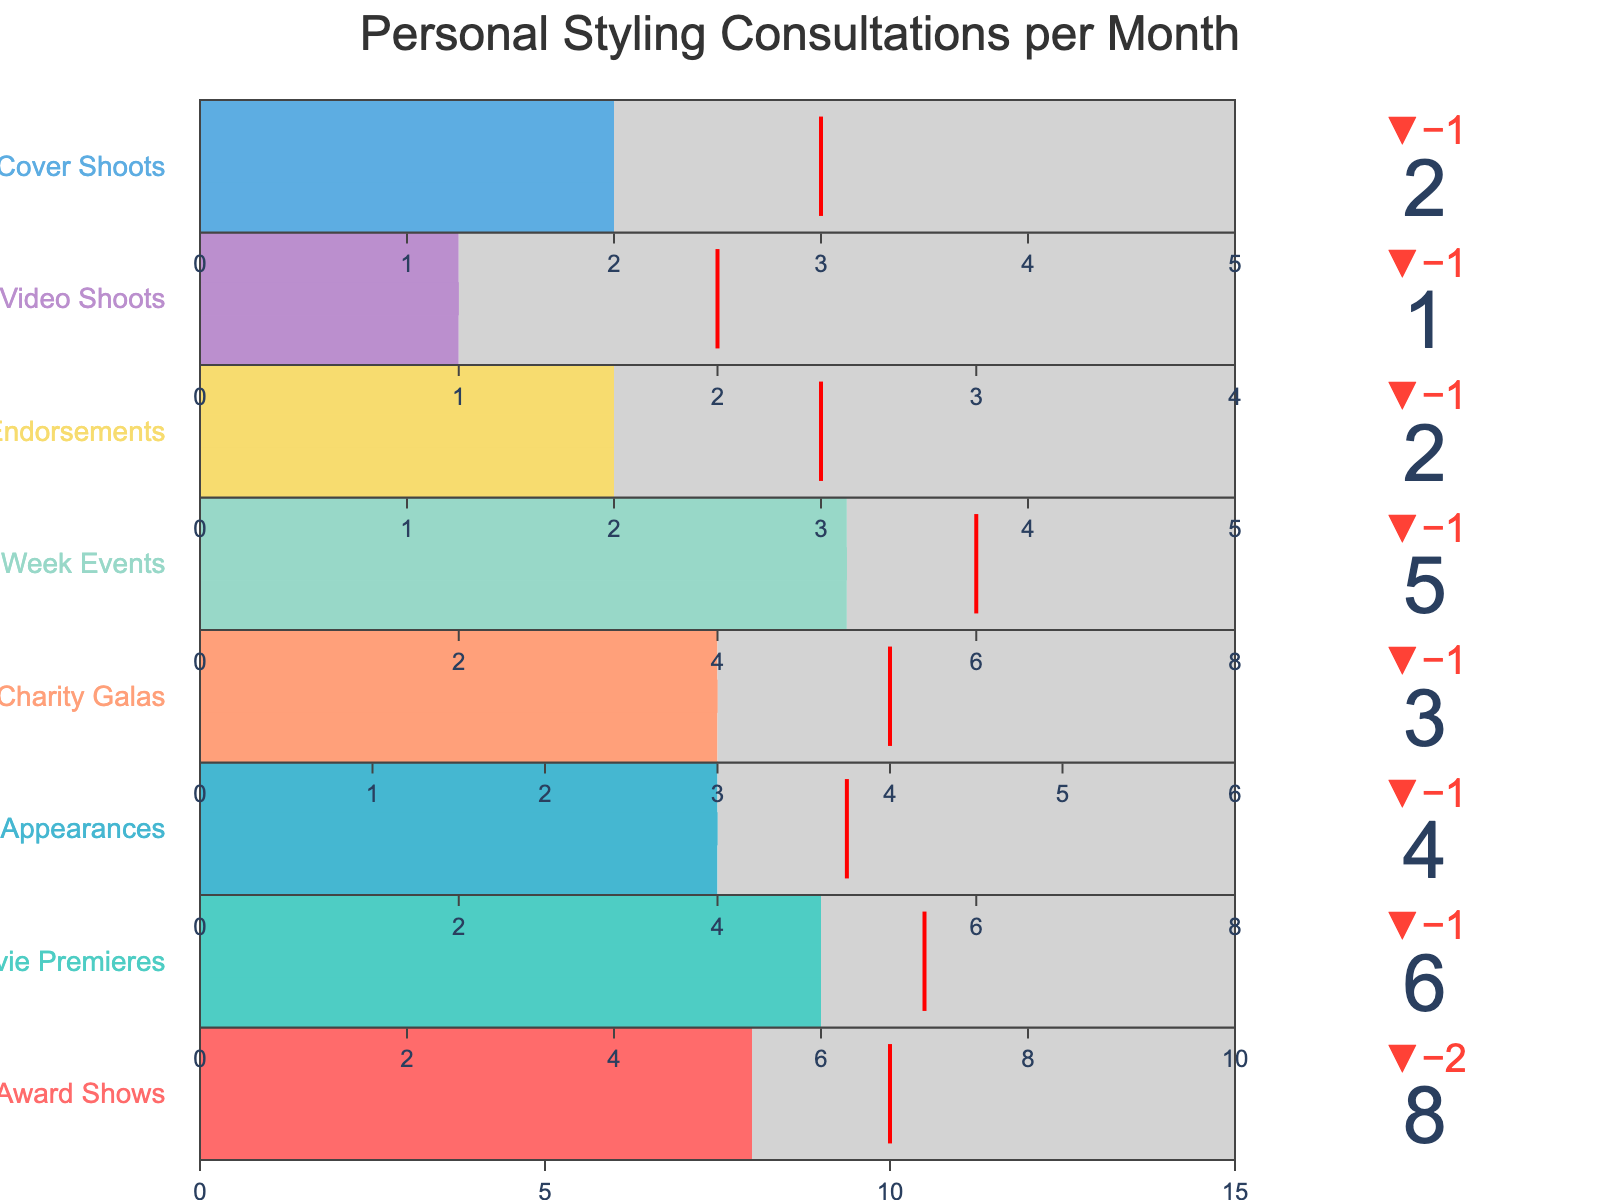What is the title of the chart? The title of the chart is displayed at the top of the figure as "Personal Styling Consultations per Month."
Answer: Personal Styling Consultations per Month What is the actual number of styling consultations for Award Shows? The figure shows an indicator for Award Shows with the actual value displayed as 8.
Answer: 8 Which event type had the highest target for styling consultations? By observing the targets displayed in the figure for each event type, Award Shows has the highest target at 10.
Answer: Award Shows How many more styling consultations are needed for Magazine Cover Shoots to reach the target? The actual value for Magazine Cover Shoots is 2, and the target is 3. Subtracting the actual from the target: 3 - 2 = 1.
Answer: 1 Compare the actual styling consultations for Charity Galas and Music Video Shoots. Charity Galas have an actual value of 3, while Music Video Shoots have an actual value of 1. Charity Galas have 2 more styling consultations than Music Video Shoots.
Answer: Charity Galas have 2 more What is the total number of actual styling consultations across all event types? Summing up the actual values for all event types: 8 + 6 + 4 + 3 + 5 + 2 + 1 + 2 = 31.
Answer: 31 Which event type has an actual number of consultations that meets or exceeds the target? The actual value for Award Shows is 8, with a target of 10 (8 does not meet the target). The actual for Movie Premieres is 6, with a target of 7 (6 does not meet the target). The actual for Talk Show Appearances is 4, with a target of 5 (4 does not meet the target), and so on for the other events. No actual values meet or exceed their respective targets.
Answer: None What is the range of maximum values depicted in the chart across different event types? The maximum values for the event types range from 4 (Music Video Shoots) to 15 (Award Shows).
Answer: 4 to 15 How many fewer styling consultations does the Brand Endorsements category have compared to its target? The actual value for Brand Endorsements is 2, and the target is 3. Subtracting the actual from the target: 3 - 2 = 1.
Answer: 1 How many event types have a maximum value of 8? The event types with a maximum value of 8 are Talk Show Appearances, Fashion Week Events, and Music Video Shoots.
Answer: 3 